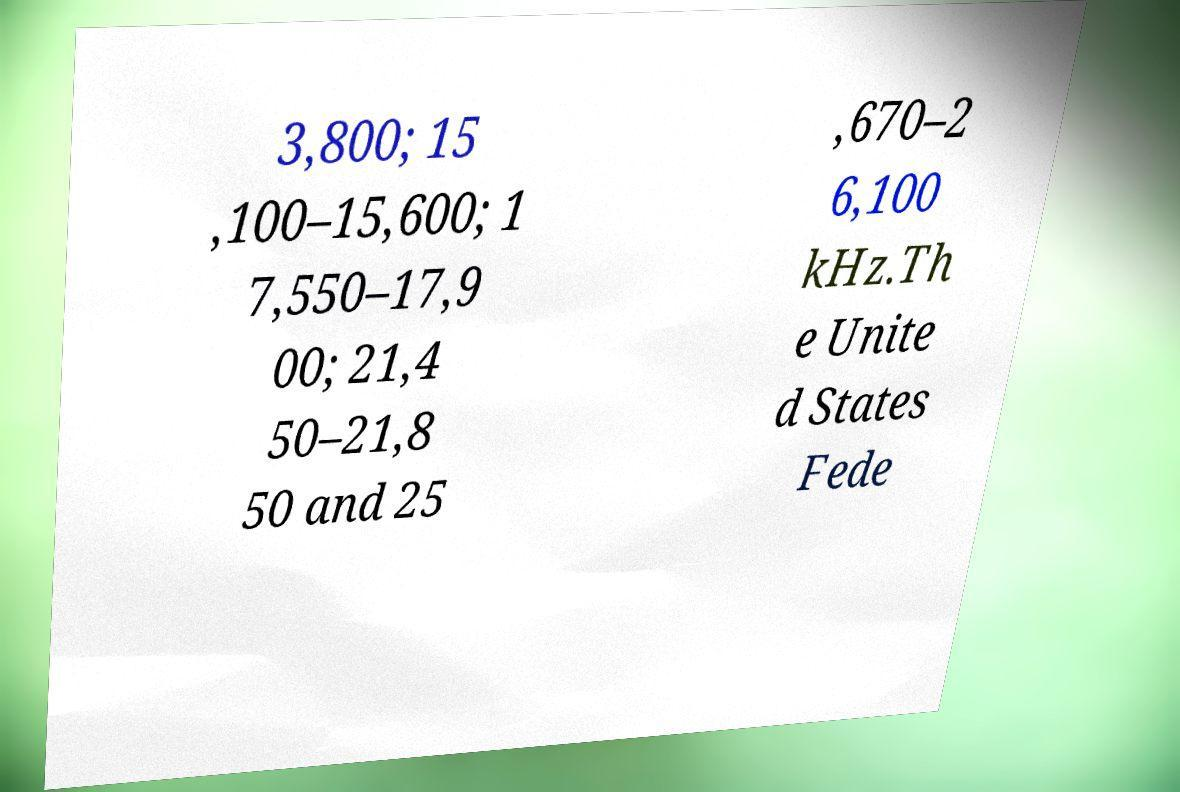Please identify and transcribe the text found in this image. 3,800; 15 ,100–15,600; 1 7,550–17,9 00; 21,4 50–21,8 50 and 25 ,670–2 6,100 kHz.Th e Unite d States Fede 